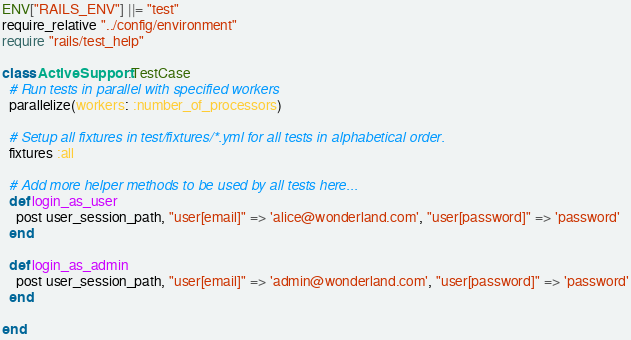Convert code to text. <code><loc_0><loc_0><loc_500><loc_500><_Ruby_>ENV["RAILS_ENV"] ||= "test"
require_relative "../config/environment"
require "rails/test_help"

class ActiveSupport::TestCase
  # Run tests in parallel with specified workers
  parallelize(workers: :number_of_processors)

  # Setup all fixtures in test/fixtures/*.yml for all tests in alphabetical order.
  fixtures :all

  # Add more helper methods to be used by all tests here...
  def login_as_user
    post user_session_path, "user[email]" => 'alice@wonderland.com', "user[password]" => 'password'
  end

  def login_as_admin
    post user_session_path, "user[email]" => 'admin@wonderland.com', "user[password]" => 'password'
  end

end
</code> 